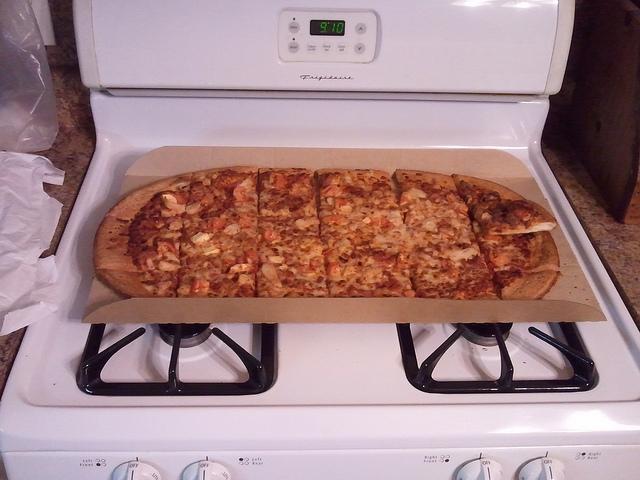How many pizzas are there?
Give a very brief answer. 3. 